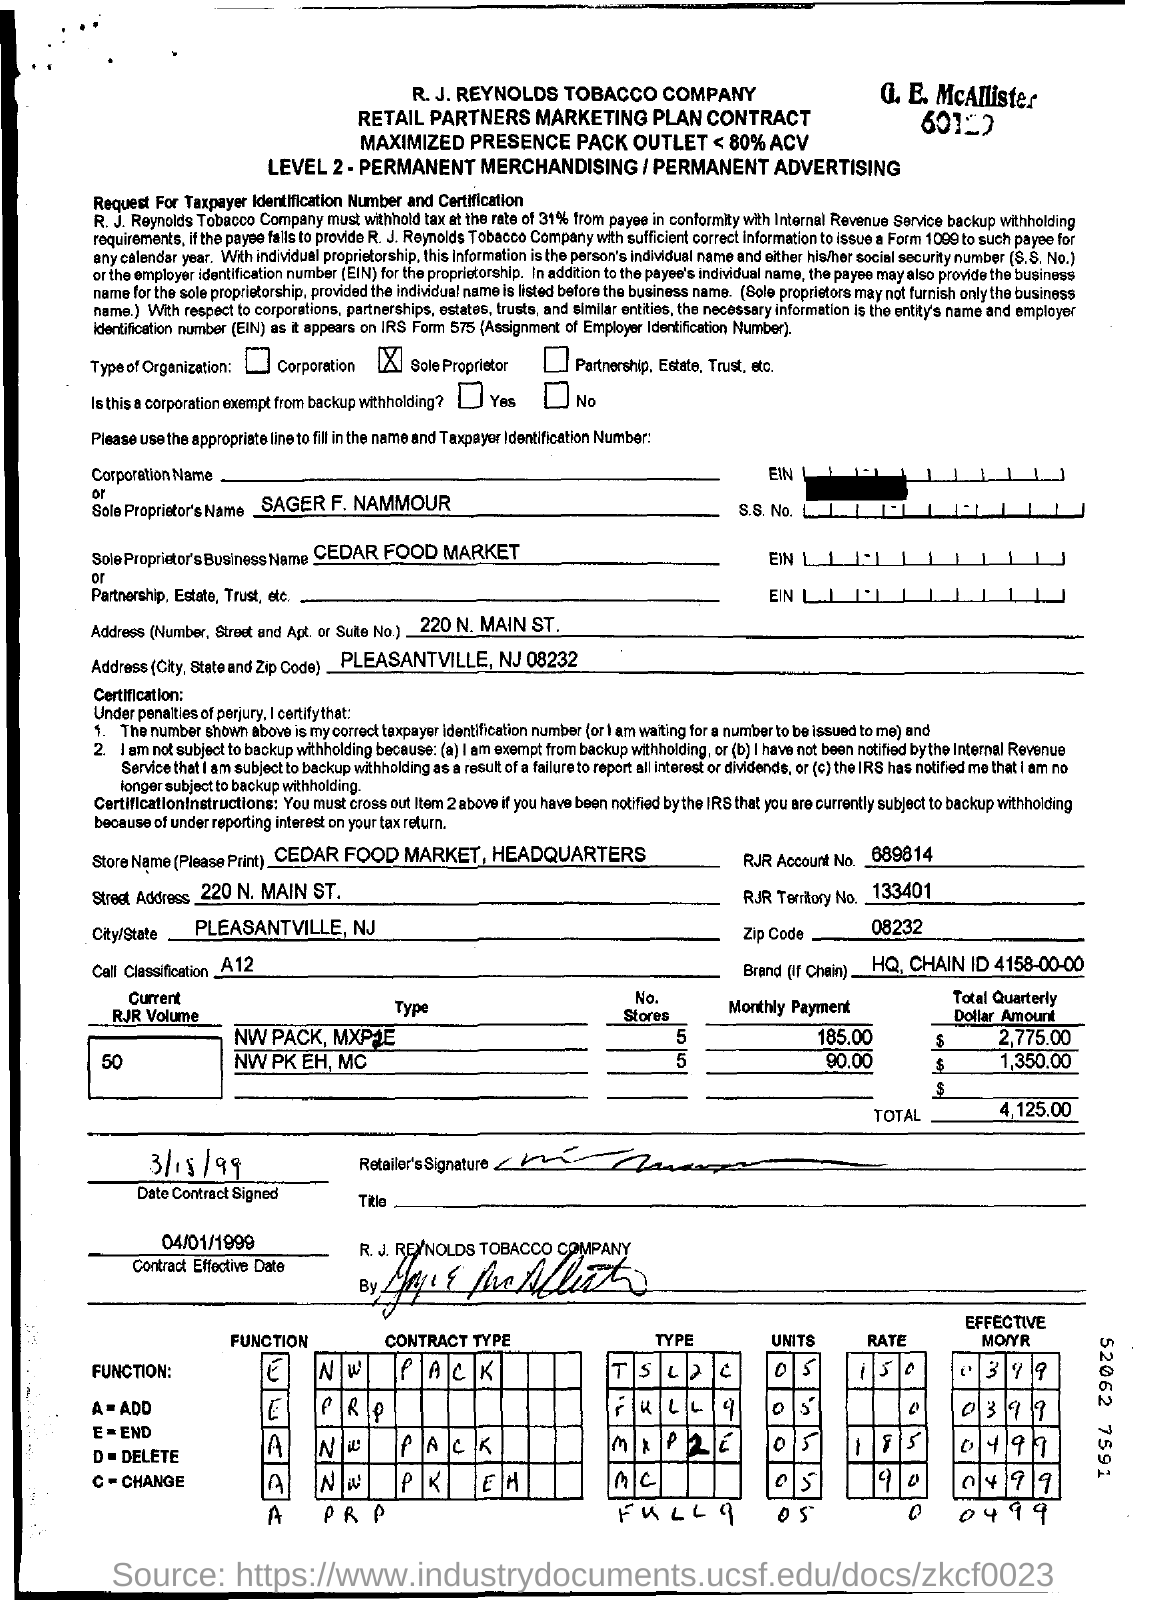What is the propreitor's business name?
Keep it short and to the point. CEDAR FOOD MARKET. What is the total amount mentioned in the contract?
Offer a terse response. 4,125.00. What is the contract effective date mentioned?
Offer a very short reply. 04/01/1999. 